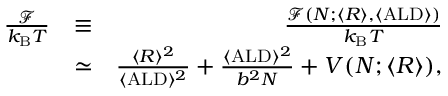Convert formula to latex. <formula><loc_0><loc_0><loc_500><loc_500>\begin{array} { r l r } { \frac { \mathcal { F } } { k _ { B } T } } & { \equiv } & { \frac { \mathcal { F } ( N ; \langle R \rangle , \langle A L D \rangle ) } { k _ { B } T } } \\ & { \simeq } & { \frac { \langle R \rangle ^ { 2 } } { \langle A L D \rangle ^ { 2 } } + \frac { \langle A L D \rangle ^ { 2 } } { b ^ { 2 } N } + V ( N ; \langle R \rangle ) , } \end{array}</formula> 